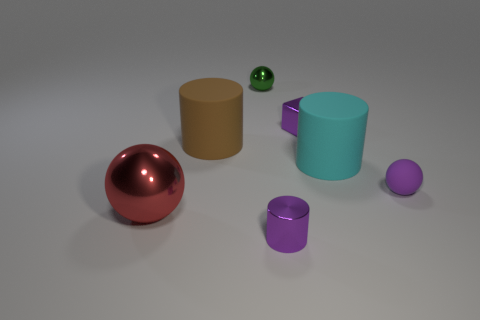There is a thing on the left side of the brown cylinder behind the big cyan object; are there any small purple metal things that are in front of it?
Offer a terse response. Yes. The tiny ball that is made of the same material as the big sphere is what color?
Ensure brevity in your answer.  Green. How many purple things are the same material as the green sphere?
Keep it short and to the point. 2. Are the purple block and the small thing that is behind the small purple cube made of the same material?
Your answer should be very brief. Yes. What number of objects are either purple metal things behind the purple sphere or purple metallic cylinders?
Make the answer very short. 2. How big is the sphere that is behind the big matte object that is right of the purple metallic object in front of the red metal sphere?
Give a very brief answer. Small. There is a block that is the same color as the tiny metallic cylinder; what material is it?
Your answer should be very brief. Metal. Is there anything else that is the same shape as the green shiny object?
Provide a succinct answer. Yes. How big is the sphere to the right of the tiny sphere that is to the left of the tiny metallic cylinder?
Offer a terse response. Small. How many large things are either shiny cylinders or matte balls?
Keep it short and to the point. 0. 